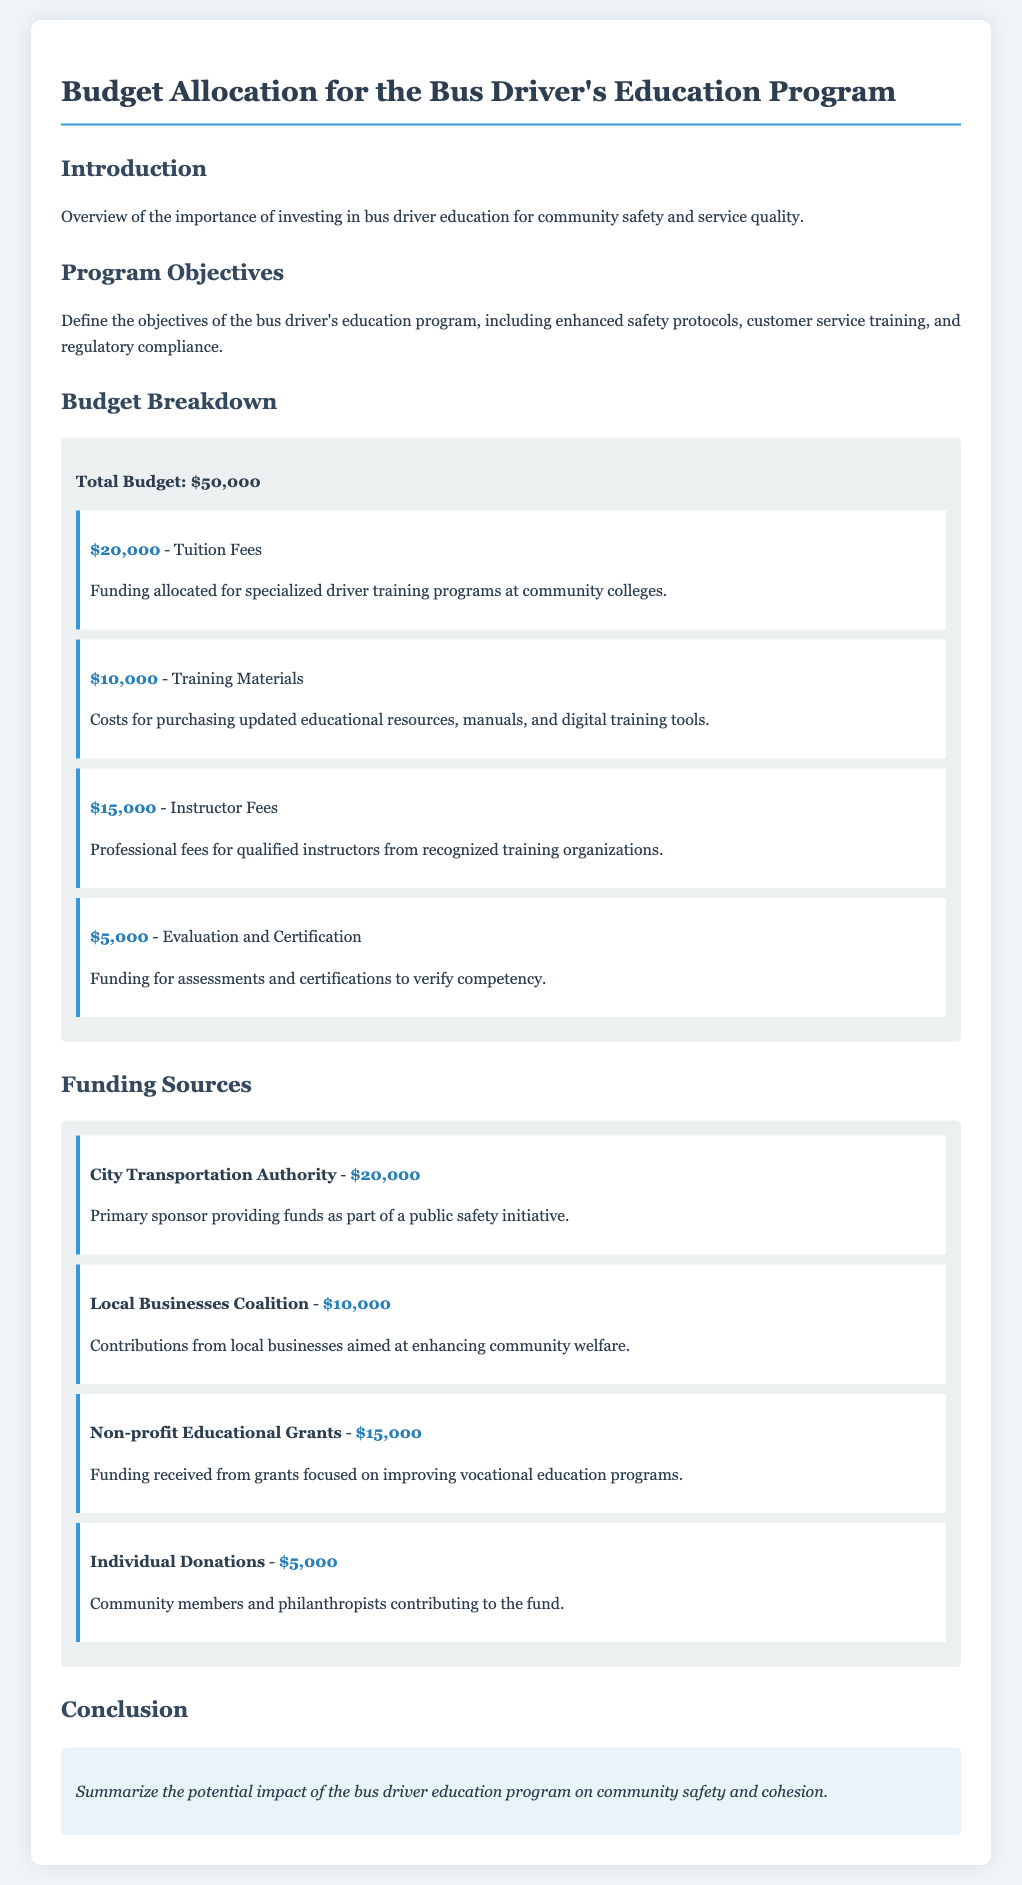What is the total budget? The total budget for the Bus Driver's Education Program is clearly specified in the budget section of the document.
Answer: $50,000 How much is allocated for tuition fees? The budget breakdown details the specific amounts allocated for each item, including tuition fees.
Answer: $20,000 What is the funding source provided by the City Transportation Authority? The document lists various funding sources along with the amounts contributed by each entity, focusing on the City Transportation Authority.
Answer: $20,000 How much funding comes from Individual Donations? The total funding from individual donations is outlined under the funding sources, specifying the amount contributed by community members and philanthropists.
Answer: $5,000 What is the purpose of the Non-profit Educational Grants? The document explains the focus of the funding received from nonprofit grants, relating it to improving vocational education programs.
Answer: Improving vocational education programs What percentage of the budget is designated for Instructor Fees? To determine the percentage of the budget for instructor fees, the amount allocated is related to the total budget figure, requiring a calculation.
Answer: 30% How many funding sources are listed in the document? The document details several funding sources, making it necessary to count them directly from the provided information.
Answer: 4 What is one objective of the bus driver's education program mentioned? The objectives of the program are summarized in the introduction, providing specific goals for the training program.
Answer: Enhanced safety protocols What type of training materials are included in the budget? The document specifies what types of materials will be funded under the training materials budget line.
Answer: Educational resources, manuals, and digital training tools How much is allocated for evaluation and certification? The budget breakdown indicates the specific amount set aside for evaluations and certifications within the program.
Answer: $5,000 